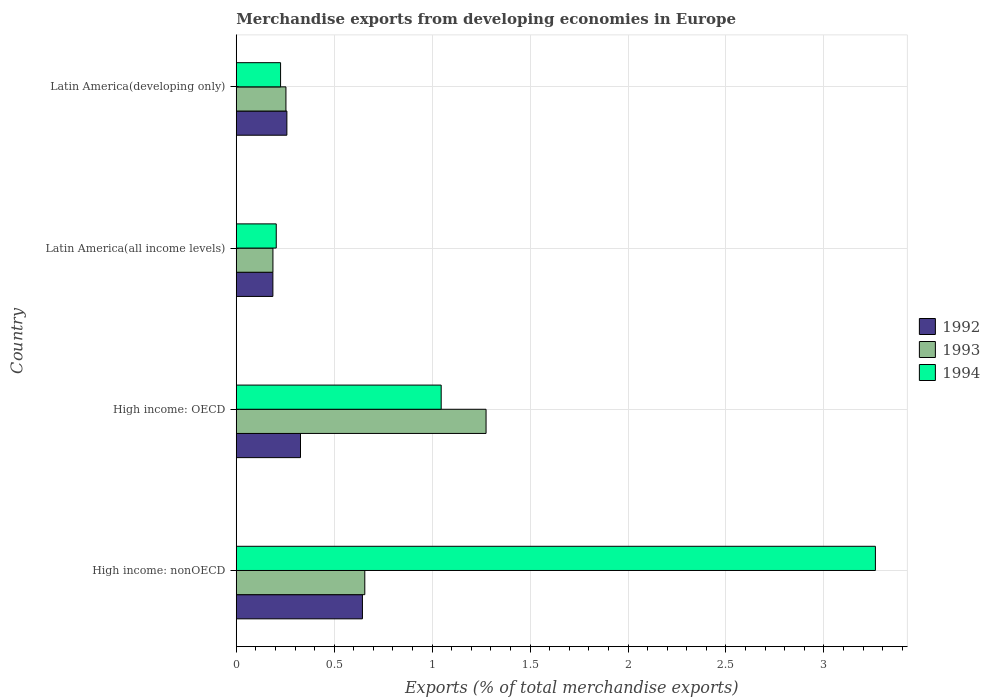How many groups of bars are there?
Give a very brief answer. 4. What is the label of the 3rd group of bars from the top?
Your response must be concise. High income: OECD. What is the percentage of total merchandise exports in 1994 in Latin America(all income levels)?
Offer a terse response. 0.2. Across all countries, what is the maximum percentage of total merchandise exports in 1994?
Your response must be concise. 3.26. Across all countries, what is the minimum percentage of total merchandise exports in 1994?
Keep it short and to the point. 0.2. In which country was the percentage of total merchandise exports in 1994 maximum?
Offer a terse response. High income: nonOECD. In which country was the percentage of total merchandise exports in 1993 minimum?
Offer a very short reply. Latin America(all income levels). What is the total percentage of total merchandise exports in 1994 in the graph?
Ensure brevity in your answer.  4.74. What is the difference between the percentage of total merchandise exports in 1993 in Latin America(all income levels) and that in Latin America(developing only)?
Your answer should be compact. -0.07. What is the difference between the percentage of total merchandise exports in 1992 in High income: OECD and the percentage of total merchandise exports in 1994 in Latin America(developing only)?
Your answer should be very brief. 0.1. What is the average percentage of total merchandise exports in 1993 per country?
Provide a succinct answer. 0.59. What is the difference between the percentage of total merchandise exports in 1994 and percentage of total merchandise exports in 1992 in Latin America(developing only)?
Offer a very short reply. -0.03. What is the ratio of the percentage of total merchandise exports in 1992 in High income: nonOECD to that in Latin America(developing only)?
Give a very brief answer. 2.49. Is the percentage of total merchandise exports in 1993 in High income: nonOECD less than that in Latin America(developing only)?
Provide a short and direct response. No. Is the difference between the percentage of total merchandise exports in 1994 in High income: OECD and Latin America(developing only) greater than the difference between the percentage of total merchandise exports in 1992 in High income: OECD and Latin America(developing only)?
Make the answer very short. Yes. What is the difference between the highest and the second highest percentage of total merchandise exports in 1994?
Provide a succinct answer. 2.22. What is the difference between the highest and the lowest percentage of total merchandise exports in 1992?
Offer a very short reply. 0.46. What does the 1st bar from the top in Latin America(all income levels) represents?
Give a very brief answer. 1994. What does the 3rd bar from the bottom in Latin America(developing only) represents?
Your answer should be compact. 1994. Are all the bars in the graph horizontal?
Provide a succinct answer. Yes. How many countries are there in the graph?
Offer a very short reply. 4. What is the difference between two consecutive major ticks on the X-axis?
Your answer should be very brief. 0.5. Are the values on the major ticks of X-axis written in scientific E-notation?
Your answer should be very brief. No. Does the graph contain any zero values?
Make the answer very short. No. What is the title of the graph?
Make the answer very short. Merchandise exports from developing economies in Europe. What is the label or title of the X-axis?
Provide a succinct answer. Exports (% of total merchandise exports). What is the Exports (% of total merchandise exports) in 1992 in High income: nonOECD?
Your answer should be compact. 0.64. What is the Exports (% of total merchandise exports) in 1993 in High income: nonOECD?
Offer a very short reply. 0.66. What is the Exports (% of total merchandise exports) of 1994 in High income: nonOECD?
Keep it short and to the point. 3.26. What is the Exports (% of total merchandise exports) in 1992 in High income: OECD?
Your response must be concise. 0.33. What is the Exports (% of total merchandise exports) in 1993 in High income: OECD?
Your answer should be compact. 1.28. What is the Exports (% of total merchandise exports) of 1994 in High income: OECD?
Give a very brief answer. 1.05. What is the Exports (% of total merchandise exports) of 1992 in Latin America(all income levels)?
Provide a short and direct response. 0.19. What is the Exports (% of total merchandise exports) of 1993 in Latin America(all income levels)?
Provide a succinct answer. 0.19. What is the Exports (% of total merchandise exports) of 1994 in Latin America(all income levels)?
Your response must be concise. 0.2. What is the Exports (% of total merchandise exports) of 1992 in Latin America(developing only)?
Your response must be concise. 0.26. What is the Exports (% of total merchandise exports) of 1993 in Latin America(developing only)?
Provide a short and direct response. 0.25. What is the Exports (% of total merchandise exports) in 1994 in Latin America(developing only)?
Offer a very short reply. 0.23. Across all countries, what is the maximum Exports (% of total merchandise exports) of 1992?
Your response must be concise. 0.64. Across all countries, what is the maximum Exports (% of total merchandise exports) of 1993?
Keep it short and to the point. 1.28. Across all countries, what is the maximum Exports (% of total merchandise exports) in 1994?
Keep it short and to the point. 3.26. Across all countries, what is the minimum Exports (% of total merchandise exports) in 1992?
Make the answer very short. 0.19. Across all countries, what is the minimum Exports (% of total merchandise exports) in 1993?
Provide a succinct answer. 0.19. Across all countries, what is the minimum Exports (% of total merchandise exports) of 1994?
Keep it short and to the point. 0.2. What is the total Exports (% of total merchandise exports) in 1992 in the graph?
Provide a succinct answer. 1.42. What is the total Exports (% of total merchandise exports) in 1993 in the graph?
Give a very brief answer. 2.37. What is the total Exports (% of total merchandise exports) of 1994 in the graph?
Provide a short and direct response. 4.74. What is the difference between the Exports (% of total merchandise exports) in 1992 in High income: nonOECD and that in High income: OECD?
Make the answer very short. 0.32. What is the difference between the Exports (% of total merchandise exports) of 1993 in High income: nonOECD and that in High income: OECD?
Ensure brevity in your answer.  -0.62. What is the difference between the Exports (% of total merchandise exports) in 1994 in High income: nonOECD and that in High income: OECD?
Provide a succinct answer. 2.22. What is the difference between the Exports (% of total merchandise exports) in 1992 in High income: nonOECD and that in Latin America(all income levels)?
Provide a short and direct response. 0.46. What is the difference between the Exports (% of total merchandise exports) of 1993 in High income: nonOECD and that in Latin America(all income levels)?
Provide a succinct answer. 0.47. What is the difference between the Exports (% of total merchandise exports) in 1994 in High income: nonOECD and that in Latin America(all income levels)?
Your answer should be compact. 3.06. What is the difference between the Exports (% of total merchandise exports) of 1992 in High income: nonOECD and that in Latin America(developing only)?
Ensure brevity in your answer.  0.39. What is the difference between the Exports (% of total merchandise exports) of 1993 in High income: nonOECD and that in Latin America(developing only)?
Your answer should be compact. 0.4. What is the difference between the Exports (% of total merchandise exports) in 1994 in High income: nonOECD and that in Latin America(developing only)?
Your answer should be very brief. 3.04. What is the difference between the Exports (% of total merchandise exports) of 1992 in High income: OECD and that in Latin America(all income levels)?
Give a very brief answer. 0.14. What is the difference between the Exports (% of total merchandise exports) of 1993 in High income: OECD and that in Latin America(all income levels)?
Offer a terse response. 1.09. What is the difference between the Exports (% of total merchandise exports) of 1994 in High income: OECD and that in Latin America(all income levels)?
Provide a short and direct response. 0.84. What is the difference between the Exports (% of total merchandise exports) of 1992 in High income: OECD and that in Latin America(developing only)?
Provide a succinct answer. 0.07. What is the difference between the Exports (% of total merchandise exports) of 1993 in High income: OECD and that in Latin America(developing only)?
Make the answer very short. 1.02. What is the difference between the Exports (% of total merchandise exports) in 1994 in High income: OECD and that in Latin America(developing only)?
Provide a short and direct response. 0.82. What is the difference between the Exports (% of total merchandise exports) in 1992 in Latin America(all income levels) and that in Latin America(developing only)?
Provide a short and direct response. -0.07. What is the difference between the Exports (% of total merchandise exports) in 1993 in Latin America(all income levels) and that in Latin America(developing only)?
Give a very brief answer. -0.07. What is the difference between the Exports (% of total merchandise exports) in 1994 in Latin America(all income levels) and that in Latin America(developing only)?
Your answer should be very brief. -0.02. What is the difference between the Exports (% of total merchandise exports) in 1992 in High income: nonOECD and the Exports (% of total merchandise exports) in 1993 in High income: OECD?
Your answer should be compact. -0.63. What is the difference between the Exports (% of total merchandise exports) of 1992 in High income: nonOECD and the Exports (% of total merchandise exports) of 1994 in High income: OECD?
Give a very brief answer. -0.4. What is the difference between the Exports (% of total merchandise exports) in 1993 in High income: nonOECD and the Exports (% of total merchandise exports) in 1994 in High income: OECD?
Offer a very short reply. -0.39. What is the difference between the Exports (% of total merchandise exports) of 1992 in High income: nonOECD and the Exports (% of total merchandise exports) of 1993 in Latin America(all income levels)?
Provide a succinct answer. 0.46. What is the difference between the Exports (% of total merchandise exports) in 1992 in High income: nonOECD and the Exports (% of total merchandise exports) in 1994 in Latin America(all income levels)?
Ensure brevity in your answer.  0.44. What is the difference between the Exports (% of total merchandise exports) of 1993 in High income: nonOECD and the Exports (% of total merchandise exports) of 1994 in Latin America(all income levels)?
Keep it short and to the point. 0.45. What is the difference between the Exports (% of total merchandise exports) of 1992 in High income: nonOECD and the Exports (% of total merchandise exports) of 1993 in Latin America(developing only)?
Make the answer very short. 0.39. What is the difference between the Exports (% of total merchandise exports) of 1992 in High income: nonOECD and the Exports (% of total merchandise exports) of 1994 in Latin America(developing only)?
Offer a very short reply. 0.42. What is the difference between the Exports (% of total merchandise exports) of 1993 in High income: nonOECD and the Exports (% of total merchandise exports) of 1994 in Latin America(developing only)?
Your answer should be very brief. 0.43. What is the difference between the Exports (% of total merchandise exports) in 1992 in High income: OECD and the Exports (% of total merchandise exports) in 1993 in Latin America(all income levels)?
Give a very brief answer. 0.14. What is the difference between the Exports (% of total merchandise exports) in 1992 in High income: OECD and the Exports (% of total merchandise exports) in 1994 in Latin America(all income levels)?
Offer a terse response. 0.12. What is the difference between the Exports (% of total merchandise exports) in 1993 in High income: OECD and the Exports (% of total merchandise exports) in 1994 in Latin America(all income levels)?
Your response must be concise. 1.07. What is the difference between the Exports (% of total merchandise exports) of 1992 in High income: OECD and the Exports (% of total merchandise exports) of 1993 in Latin America(developing only)?
Your answer should be very brief. 0.07. What is the difference between the Exports (% of total merchandise exports) of 1992 in High income: OECD and the Exports (% of total merchandise exports) of 1994 in Latin America(developing only)?
Your answer should be very brief. 0.1. What is the difference between the Exports (% of total merchandise exports) in 1993 in High income: OECD and the Exports (% of total merchandise exports) in 1994 in Latin America(developing only)?
Ensure brevity in your answer.  1.05. What is the difference between the Exports (% of total merchandise exports) in 1992 in Latin America(all income levels) and the Exports (% of total merchandise exports) in 1993 in Latin America(developing only)?
Ensure brevity in your answer.  -0.07. What is the difference between the Exports (% of total merchandise exports) of 1992 in Latin America(all income levels) and the Exports (% of total merchandise exports) of 1994 in Latin America(developing only)?
Provide a succinct answer. -0.04. What is the difference between the Exports (% of total merchandise exports) in 1993 in Latin America(all income levels) and the Exports (% of total merchandise exports) in 1994 in Latin America(developing only)?
Make the answer very short. -0.04. What is the average Exports (% of total merchandise exports) of 1992 per country?
Provide a succinct answer. 0.35. What is the average Exports (% of total merchandise exports) in 1993 per country?
Make the answer very short. 0.59. What is the average Exports (% of total merchandise exports) of 1994 per country?
Offer a very short reply. 1.19. What is the difference between the Exports (% of total merchandise exports) of 1992 and Exports (% of total merchandise exports) of 1993 in High income: nonOECD?
Give a very brief answer. -0.01. What is the difference between the Exports (% of total merchandise exports) in 1992 and Exports (% of total merchandise exports) in 1994 in High income: nonOECD?
Keep it short and to the point. -2.62. What is the difference between the Exports (% of total merchandise exports) of 1993 and Exports (% of total merchandise exports) of 1994 in High income: nonOECD?
Ensure brevity in your answer.  -2.61. What is the difference between the Exports (% of total merchandise exports) of 1992 and Exports (% of total merchandise exports) of 1993 in High income: OECD?
Your answer should be compact. -0.95. What is the difference between the Exports (% of total merchandise exports) in 1992 and Exports (% of total merchandise exports) in 1994 in High income: OECD?
Your response must be concise. -0.72. What is the difference between the Exports (% of total merchandise exports) in 1993 and Exports (% of total merchandise exports) in 1994 in High income: OECD?
Make the answer very short. 0.23. What is the difference between the Exports (% of total merchandise exports) of 1992 and Exports (% of total merchandise exports) of 1993 in Latin America(all income levels)?
Offer a terse response. -0. What is the difference between the Exports (% of total merchandise exports) of 1992 and Exports (% of total merchandise exports) of 1994 in Latin America(all income levels)?
Ensure brevity in your answer.  -0.02. What is the difference between the Exports (% of total merchandise exports) of 1993 and Exports (% of total merchandise exports) of 1994 in Latin America(all income levels)?
Make the answer very short. -0.02. What is the difference between the Exports (% of total merchandise exports) in 1992 and Exports (% of total merchandise exports) in 1993 in Latin America(developing only)?
Keep it short and to the point. 0. What is the difference between the Exports (% of total merchandise exports) in 1992 and Exports (% of total merchandise exports) in 1994 in Latin America(developing only)?
Provide a succinct answer. 0.03. What is the difference between the Exports (% of total merchandise exports) of 1993 and Exports (% of total merchandise exports) of 1994 in Latin America(developing only)?
Keep it short and to the point. 0.03. What is the ratio of the Exports (% of total merchandise exports) of 1992 in High income: nonOECD to that in High income: OECD?
Provide a short and direct response. 1.96. What is the ratio of the Exports (% of total merchandise exports) in 1993 in High income: nonOECD to that in High income: OECD?
Keep it short and to the point. 0.51. What is the ratio of the Exports (% of total merchandise exports) of 1994 in High income: nonOECD to that in High income: OECD?
Your answer should be compact. 3.12. What is the ratio of the Exports (% of total merchandise exports) of 1992 in High income: nonOECD to that in Latin America(all income levels)?
Your answer should be very brief. 3.44. What is the ratio of the Exports (% of total merchandise exports) of 1993 in High income: nonOECD to that in Latin America(all income levels)?
Give a very brief answer. 3.5. What is the ratio of the Exports (% of total merchandise exports) in 1994 in High income: nonOECD to that in Latin America(all income levels)?
Make the answer very short. 15.98. What is the ratio of the Exports (% of total merchandise exports) of 1992 in High income: nonOECD to that in Latin America(developing only)?
Offer a very short reply. 2.49. What is the ratio of the Exports (% of total merchandise exports) in 1993 in High income: nonOECD to that in Latin America(developing only)?
Your answer should be compact. 2.59. What is the ratio of the Exports (% of total merchandise exports) of 1994 in High income: nonOECD to that in Latin America(developing only)?
Offer a very short reply. 14.42. What is the ratio of the Exports (% of total merchandise exports) in 1992 in High income: OECD to that in Latin America(all income levels)?
Your answer should be compact. 1.75. What is the ratio of the Exports (% of total merchandise exports) of 1993 in High income: OECD to that in Latin America(all income levels)?
Offer a terse response. 6.81. What is the ratio of the Exports (% of total merchandise exports) in 1994 in High income: OECD to that in Latin America(all income levels)?
Offer a very short reply. 5.12. What is the ratio of the Exports (% of total merchandise exports) of 1992 in High income: OECD to that in Latin America(developing only)?
Your answer should be very brief. 1.27. What is the ratio of the Exports (% of total merchandise exports) of 1993 in High income: OECD to that in Latin America(developing only)?
Your answer should be very brief. 5.03. What is the ratio of the Exports (% of total merchandise exports) in 1994 in High income: OECD to that in Latin America(developing only)?
Offer a very short reply. 4.62. What is the ratio of the Exports (% of total merchandise exports) of 1992 in Latin America(all income levels) to that in Latin America(developing only)?
Provide a short and direct response. 0.72. What is the ratio of the Exports (% of total merchandise exports) of 1993 in Latin America(all income levels) to that in Latin America(developing only)?
Your answer should be very brief. 0.74. What is the ratio of the Exports (% of total merchandise exports) of 1994 in Latin America(all income levels) to that in Latin America(developing only)?
Offer a terse response. 0.9. What is the difference between the highest and the second highest Exports (% of total merchandise exports) of 1992?
Offer a very short reply. 0.32. What is the difference between the highest and the second highest Exports (% of total merchandise exports) in 1993?
Give a very brief answer. 0.62. What is the difference between the highest and the second highest Exports (% of total merchandise exports) in 1994?
Offer a terse response. 2.22. What is the difference between the highest and the lowest Exports (% of total merchandise exports) in 1992?
Your answer should be very brief. 0.46. What is the difference between the highest and the lowest Exports (% of total merchandise exports) of 1993?
Offer a very short reply. 1.09. What is the difference between the highest and the lowest Exports (% of total merchandise exports) in 1994?
Your answer should be compact. 3.06. 